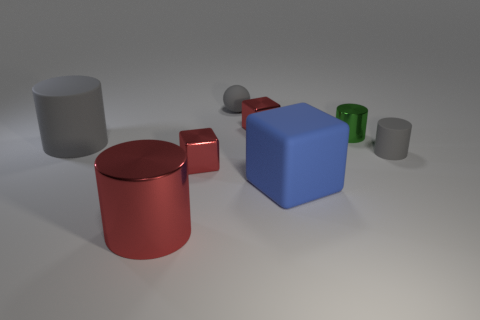Are there any other things that are the same color as the big metal cylinder?
Keep it short and to the point. Yes. What material is the small gray sphere that is behind the small gray matte object that is in front of the tiny block behind the small rubber cylinder?
Keep it short and to the point. Rubber. How many shiny objects are either blue blocks or small red things?
Offer a terse response. 2. Do the large matte cylinder and the tiny rubber cylinder have the same color?
Keep it short and to the point. Yes. Are there any other things that have the same material as the tiny green cylinder?
Your answer should be compact. Yes. How many objects are large blue metallic blocks or red things that are behind the big red shiny cylinder?
Your answer should be compact. 2. Is the size of the red metal block to the right of the rubber ball the same as the big red metal cylinder?
Your response must be concise. No. How many other objects are there of the same shape as the blue thing?
Provide a short and direct response. 2. How many yellow objects are metal things or metal blocks?
Give a very brief answer. 0. Do the large cylinder that is behind the large red thing and the tiny rubber cylinder have the same color?
Offer a terse response. Yes. 